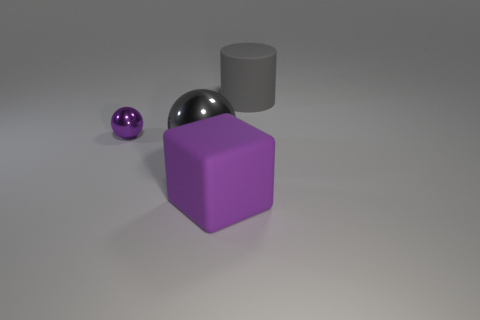Is there another purple ball of the same size as the purple metallic sphere? No, there is not another ball of the same size and color as the purple metallic sphere in the image. 